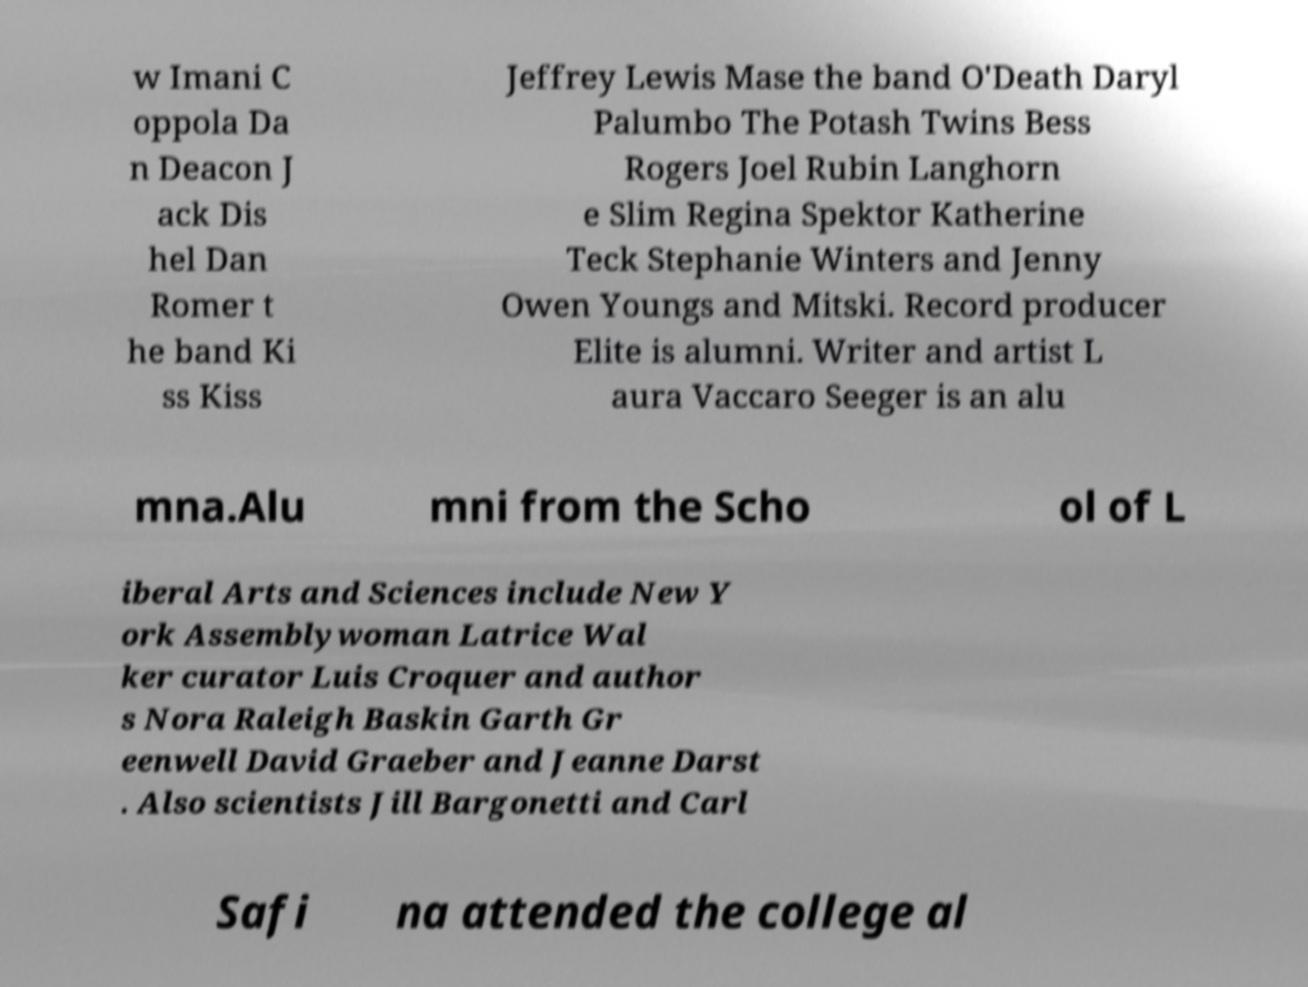Please read and relay the text visible in this image. What does it say? w Imani C oppola Da n Deacon J ack Dis hel Dan Romer t he band Ki ss Kiss Jeffrey Lewis Mase the band O'Death Daryl Palumbo The Potash Twins Bess Rogers Joel Rubin Langhorn e Slim Regina Spektor Katherine Teck Stephanie Winters and Jenny Owen Youngs and Mitski. Record producer Elite is alumni. Writer and artist L aura Vaccaro Seeger is an alu mna.Alu mni from the Scho ol of L iberal Arts and Sciences include New Y ork Assemblywoman Latrice Wal ker curator Luis Croquer and author s Nora Raleigh Baskin Garth Gr eenwell David Graeber and Jeanne Darst . Also scientists Jill Bargonetti and Carl Safi na attended the college al 